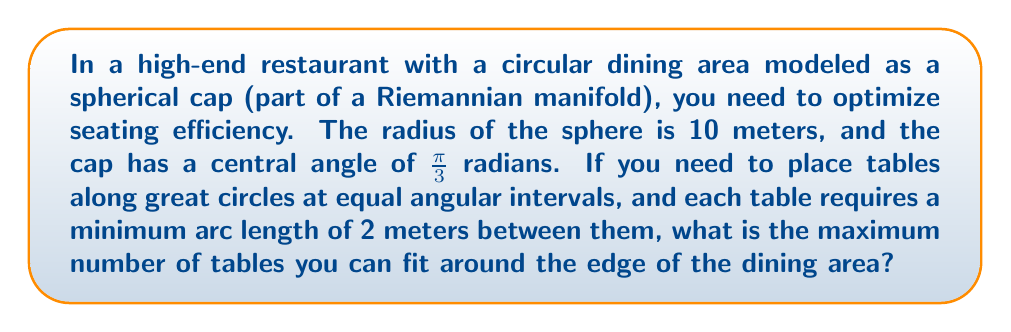Give your solution to this math problem. Let's approach this step-by-step:

1) In a spherical geometry, the arc length $s$ along a great circle is related to the central angle $\theta$ and radius $r$ by the formula:

   $s = r\theta$

2) The circumference of the circular dining area (spherical cap) is given by:

   $C = 2\pi r \sin(\alpha/2)$

   where $\alpha$ is the central angle of the cap.

3) Substituting the given values:
   $r = 10$ m, $\alpha = \frac{\pi}{3}$ rad

   $C = 2\pi(10)\sin(\frac{\pi}{6}) = 20\pi \sin(\frac{\pi}{6}) \approx 31.4159$ m

4) The minimum arc length between tables is 2 m. In the spherical geometry, this corresponds to an angle $\theta$ at the center:

   $2 = 10\theta$
   $\theta = 0.2$ rad

5) The number of tables we can fit is the floor of the ratio of the circumference to the minimum spacing:

   $N = \lfloor \frac{C}{2} \rfloor = \lfloor \frac{31.4159}{2} \rfloor = 15$

Therefore, you can fit a maximum of 15 tables around the edge of the dining area.
Answer: 15 tables 